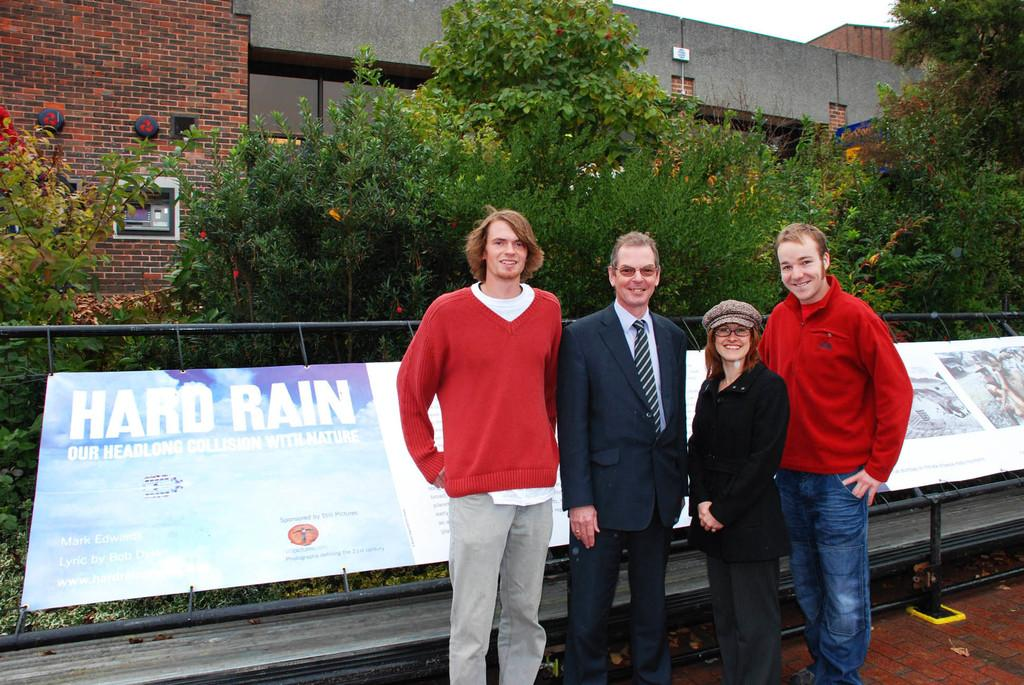What can be seen in the foreground of the image? There are persons standing in the foreground of the image. What is located in the background of the image? There is a board, poles, houses, and trees in the background of the image. What type of pathway is visible at the bottom of the image? There is a walkway at the bottom of the image. What type of pear is being used by the beginner in the image? There is no pear or beginner present in the image. What is the health status of the persons standing in the foreground? The health status of the persons standing in the foreground cannot be determined from the image. 